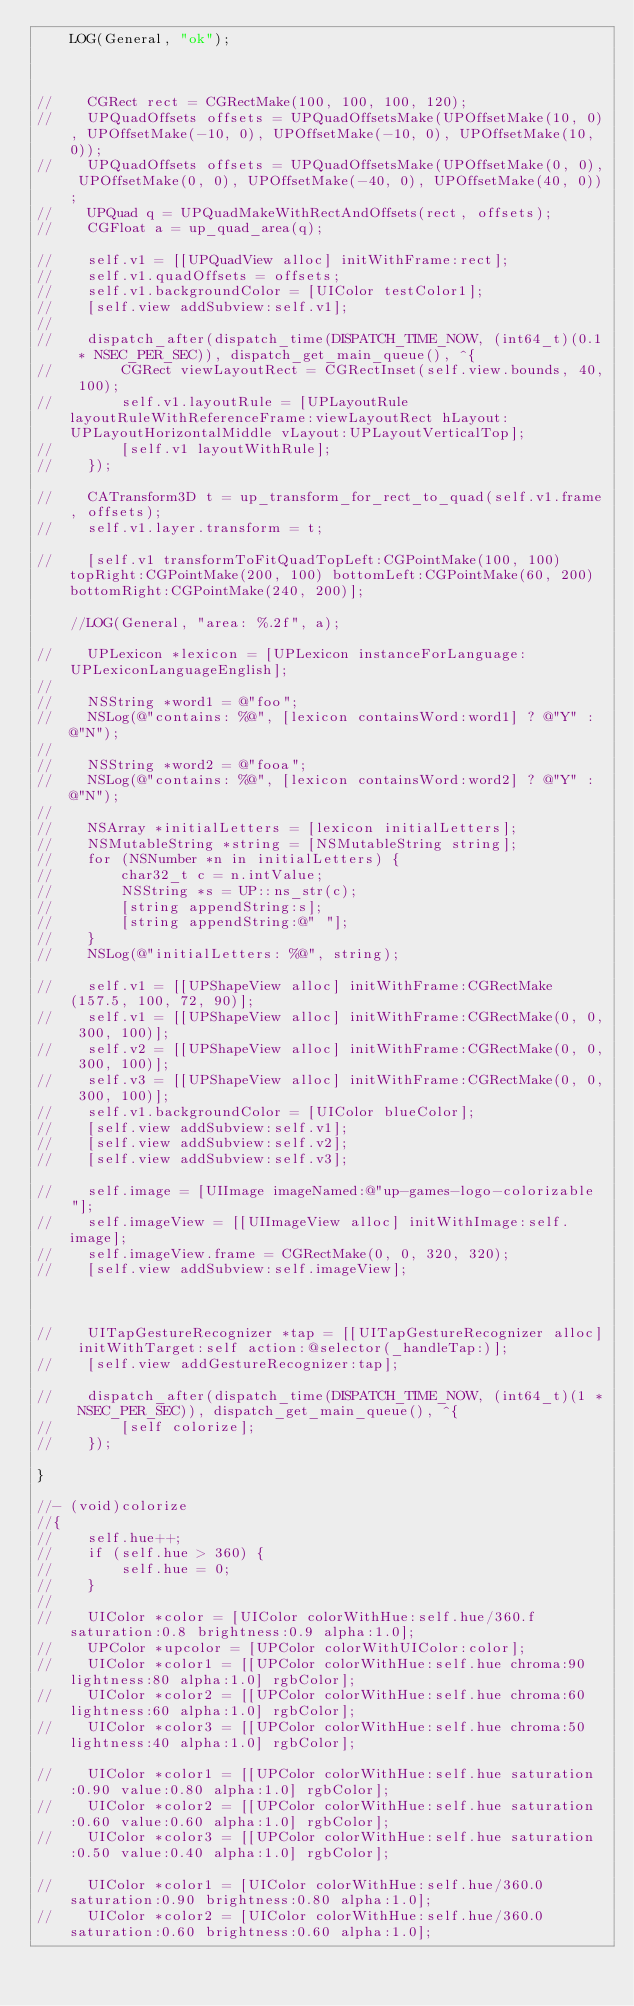<code> <loc_0><loc_0><loc_500><loc_500><_ObjectiveC_>    LOG(General, "ok");

    
    
//    CGRect rect = CGRectMake(100, 100, 100, 120);
//    UPQuadOffsets offsets = UPQuadOffsetsMake(UPOffsetMake(10, 0), UPOffsetMake(-10, 0), UPOffsetMake(-10, 0), UPOffsetMake(10, 0));
//    UPQuadOffsets offsets = UPQuadOffsetsMake(UPOffsetMake(0, 0), UPOffsetMake(0, 0), UPOffsetMake(-40, 0), UPOffsetMake(40, 0));
//    UPQuad q = UPQuadMakeWithRectAndOffsets(rect, offsets);
//    CGFloat a = up_quad_area(q);

//    self.v1 = [[UPQuadView alloc] initWithFrame:rect];
//    self.v1.quadOffsets = offsets;
//    self.v1.backgroundColor = [UIColor testColor1];
//    [self.view addSubview:self.v1];
//
//    dispatch_after(dispatch_time(DISPATCH_TIME_NOW, (int64_t)(0.1 * NSEC_PER_SEC)), dispatch_get_main_queue(), ^{
//        CGRect viewLayoutRect = CGRectInset(self.view.bounds, 40, 100);
//        self.v1.layoutRule = [UPLayoutRule layoutRuleWithReferenceFrame:viewLayoutRect hLayout:UPLayoutHorizontalMiddle vLayout:UPLayoutVerticalTop];
//        [self.v1 layoutWithRule];
//    });
    
//    CATransform3D t = up_transform_for_rect_to_quad(self.v1.frame, offsets);
//    self.v1.layer.transform = t;

//    [self.v1 transformToFitQuadTopLeft:CGPointMake(100, 100) topRight:CGPointMake(200, 100) bottomLeft:CGPointMake(60, 200) bottomRight:CGPointMake(240, 200)];

    //LOG(General, "area: %.2f", a);

//    UPLexicon *lexicon = [UPLexicon instanceForLanguage:UPLexiconLanguageEnglish];
//
//    NSString *word1 = @"foo";
//    NSLog(@"contains: %@", [lexicon containsWord:word1] ? @"Y" : @"N");
//
//    NSString *word2 = @"fooa";
//    NSLog(@"contains: %@", [lexicon containsWord:word2] ? @"Y" : @"N");
//
//    NSArray *initialLetters = [lexicon initialLetters];
//    NSMutableString *string = [NSMutableString string];
//    for (NSNumber *n in initialLetters) {
//        char32_t c = n.intValue;
//        NSString *s = UP::ns_str(c);
//        [string appendString:s];
//        [string appendString:@" "];
//    }
//    NSLog(@"initialLetters: %@", string);

//    self.v1 = [[UPShapeView alloc] initWithFrame:CGRectMake(157.5, 100, 72, 90)];
//    self.v1 = [[UPShapeView alloc] initWithFrame:CGRectMake(0, 0, 300, 100)];
//    self.v2 = [[UPShapeView alloc] initWithFrame:CGRectMake(0, 0, 300, 100)];
//    self.v3 = [[UPShapeView alloc] initWithFrame:CGRectMake(0, 0, 300, 100)];
//    self.v1.backgroundColor = [UIColor blueColor];
//    [self.view addSubview:self.v1];
//    [self.view addSubview:self.v2];
//    [self.view addSubview:self.v3];
  
//    self.image = [UIImage imageNamed:@"up-games-logo-colorizable"];
//    self.imageView = [[UIImageView alloc] initWithImage:self.image];
//    self.imageView.frame = CGRectMake(0, 0, 320, 320);
//    [self.view addSubview:self.imageView];

    

//    UITapGestureRecognizer *tap = [[UITapGestureRecognizer alloc] initWithTarget:self action:@selector(_handleTap:)];
//    [self.view addGestureRecognizer:tap];

//    dispatch_after(dispatch_time(DISPATCH_TIME_NOW, (int64_t)(1 * NSEC_PER_SEC)), dispatch_get_main_queue(), ^{
//        [self colorize];
//    });

}

//- (void)colorize
//{
//    self.hue++;
//    if (self.hue > 360) {
//        self.hue = 0;
//    }
//
//    UIColor *color = [UIColor colorWithHue:self.hue/360.f saturation:0.8 brightness:0.9 alpha:1.0];
//    UPColor *upcolor = [UPColor colorWithUIColor:color];
//    UIColor *color1 = [[UPColor colorWithHue:self.hue chroma:90 lightness:80 alpha:1.0] rgbColor];
//    UIColor *color2 = [[UPColor colorWithHue:self.hue chroma:60 lightness:60 alpha:1.0] rgbColor];
//    UIColor *color3 = [[UPColor colorWithHue:self.hue chroma:50 lightness:40 alpha:1.0] rgbColor];

//    UIColor *color1 = [[UPColor colorWithHue:self.hue saturation:0.90 value:0.80 alpha:1.0] rgbColor];
//    UIColor *color2 = [[UPColor colorWithHue:self.hue saturation:0.60 value:0.60 alpha:1.0] rgbColor];
//    UIColor *color3 = [[UPColor colorWithHue:self.hue saturation:0.50 value:0.40 alpha:1.0] rgbColor];

//    UIColor *color1 = [UIColor colorWithHue:self.hue/360.0 saturation:0.90 brightness:0.80 alpha:1.0];
//    UIColor *color2 = [UIColor colorWithHue:self.hue/360.0 saturation:0.60 brightness:0.60 alpha:1.0];</code> 